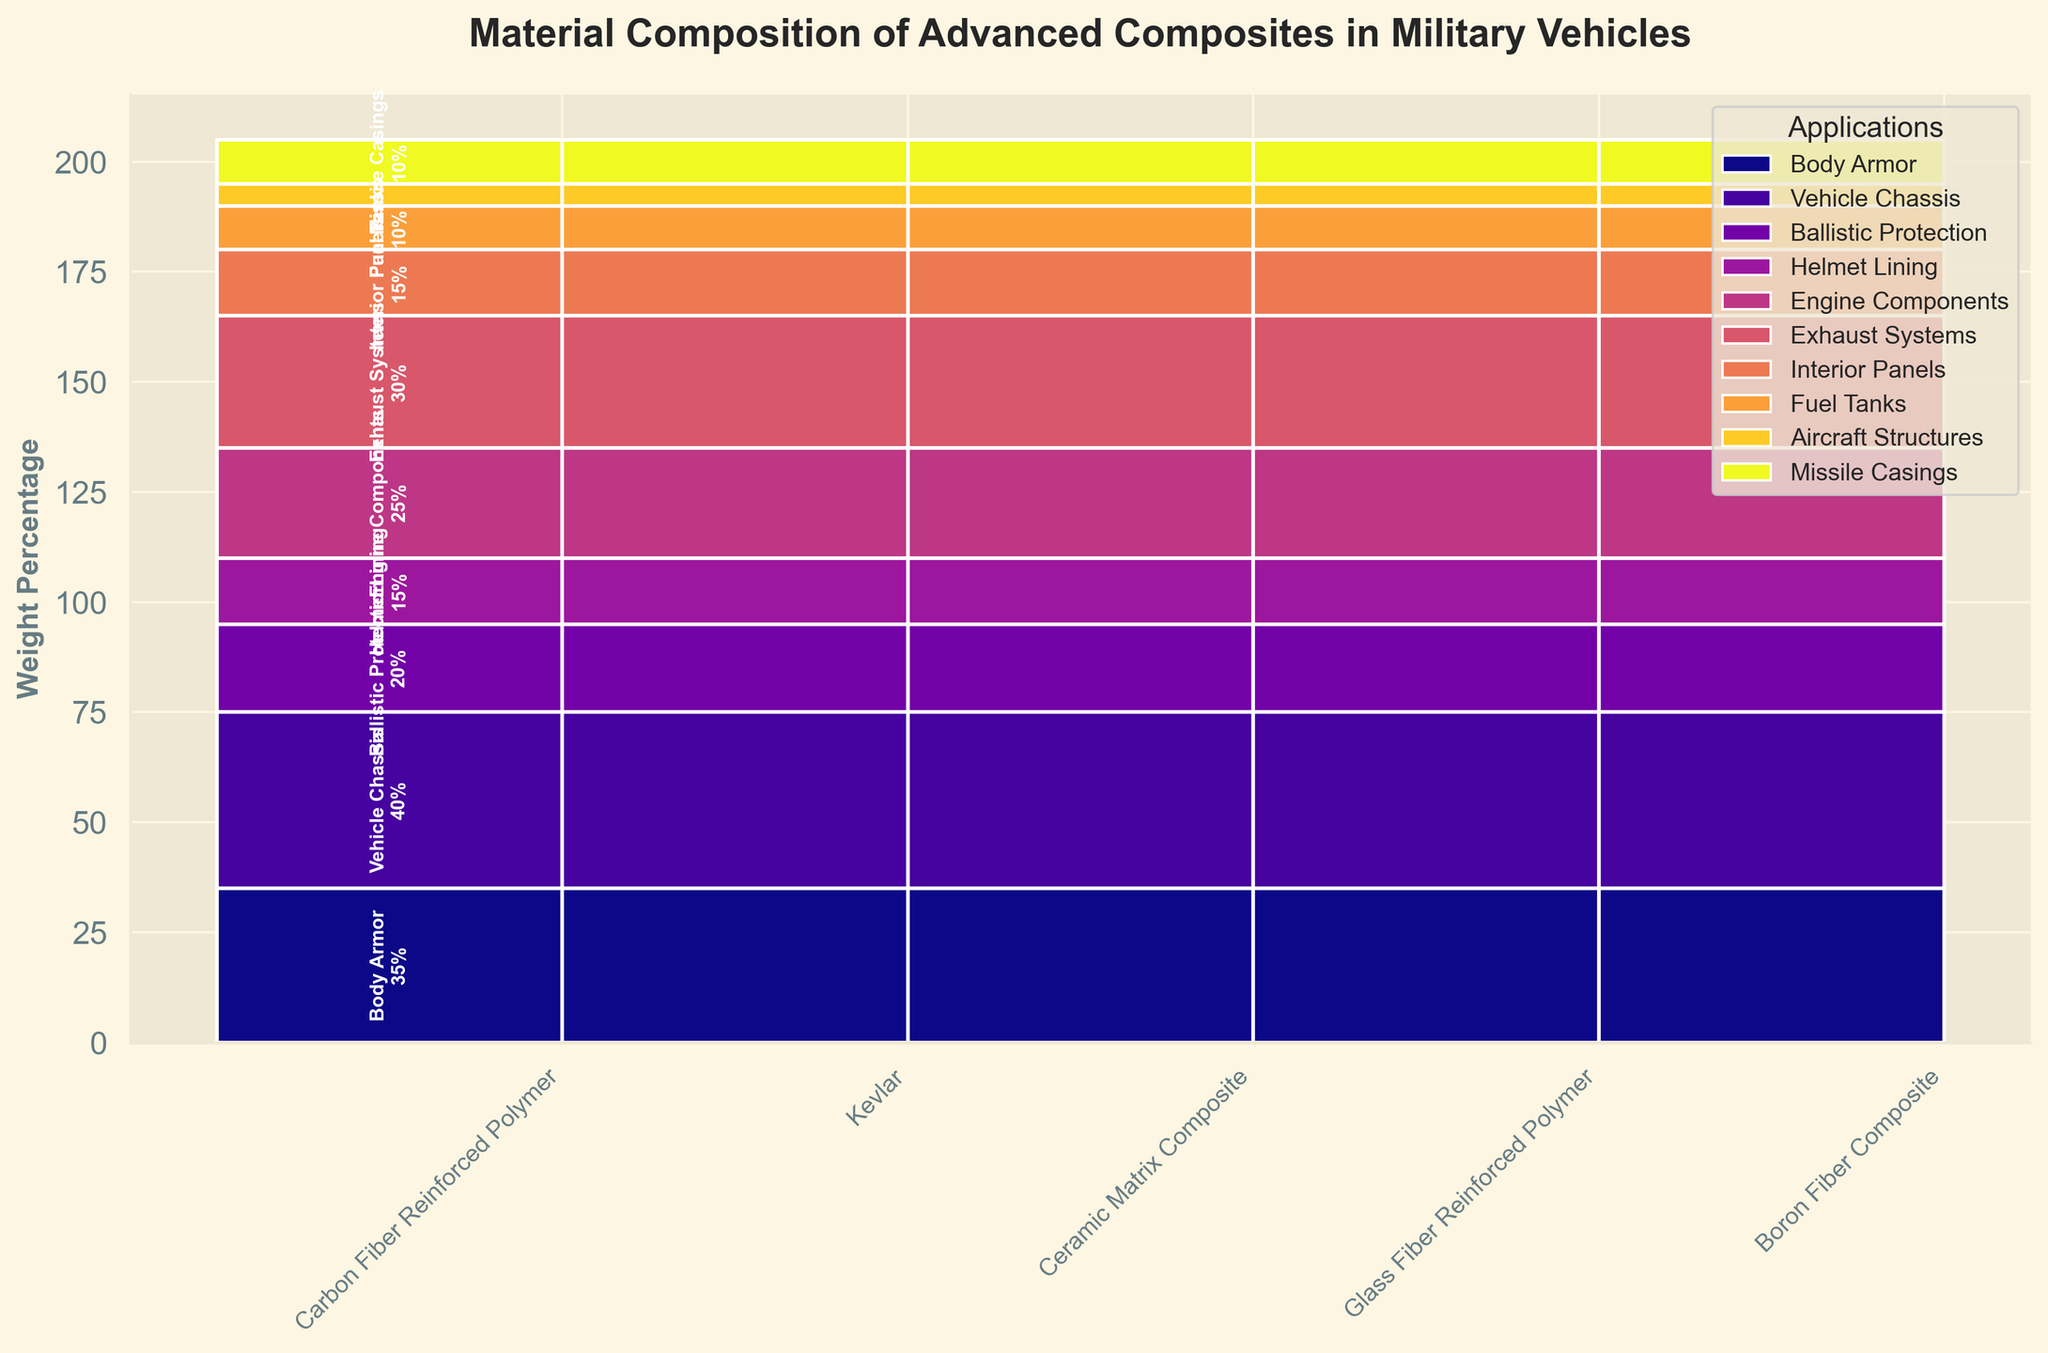What is the title of the plot? The title is located at the top of the figure and is written in a larger, bold font.
Answer: Material Composition of Advanced Composites in Military Vehicles What is the weight percentage of Kevlar used in ballistic protection? To find this, look for the section labeled "Ballistic Protection" and identify the bar associated with "Kevlar". The weight percentage should be indicated within the bar.
Answer: 20% How many different materials are shown in the plot? Count the number of unique material names along the X-axis.
Answer: 5 Which material has the highest weight percentage for a single application? Scan the bars for the highest value of weight percentage. Each bar represents one application.
Answer: Carbon Fiber Reinforced Polymer (Vehicle Chassis) What is the weight percentage range for Ceramic Matrix Composite applications? Identify the bars associated with Ceramic Matrix Composite and note the highest and lowest weight percentages listed within those bars.
Answer: 25% - 30% Which application has the lowest weight percentage contribution? Look for the smallest percentage value labeled within any application section.
Answer: Fuel Tanks How does the combined weight percentage of Kevlar compare to Carbon Fiber Reinforced Polymer? Sum the weight percentages for Kevlar (Ballistic Protection and Helmet Lining) and Carbon Fiber Reinforced Polymer (Body Armor and Vehicle Chassis), then compare the two sums. Kevlar: 20% + 15% = 35%, Carbon Fiber Reinforced Polymer: 35% + 40% = 75%. Therefore, Carbon Fiber Reinforced Polymer has a higher combined weight percentage.
Answer: Carbon Fiber Reinforced Polymer Which application has the most varied material composition by weight? Look for the application whose bars vary the most in height (weight percentage) across different materials.
Answer: Body Armor What is the total weight percentage of all the compositional applications in the plot? Sum up all the weight percentages from all materials and their respective applications.
Answer: 200% Which material has the most balanced weight percentage across all applications? Look for the material whose bars (weight percentages across applications) are most similar to each other.
Answer: Glass Fiber Reinforced Polymer 